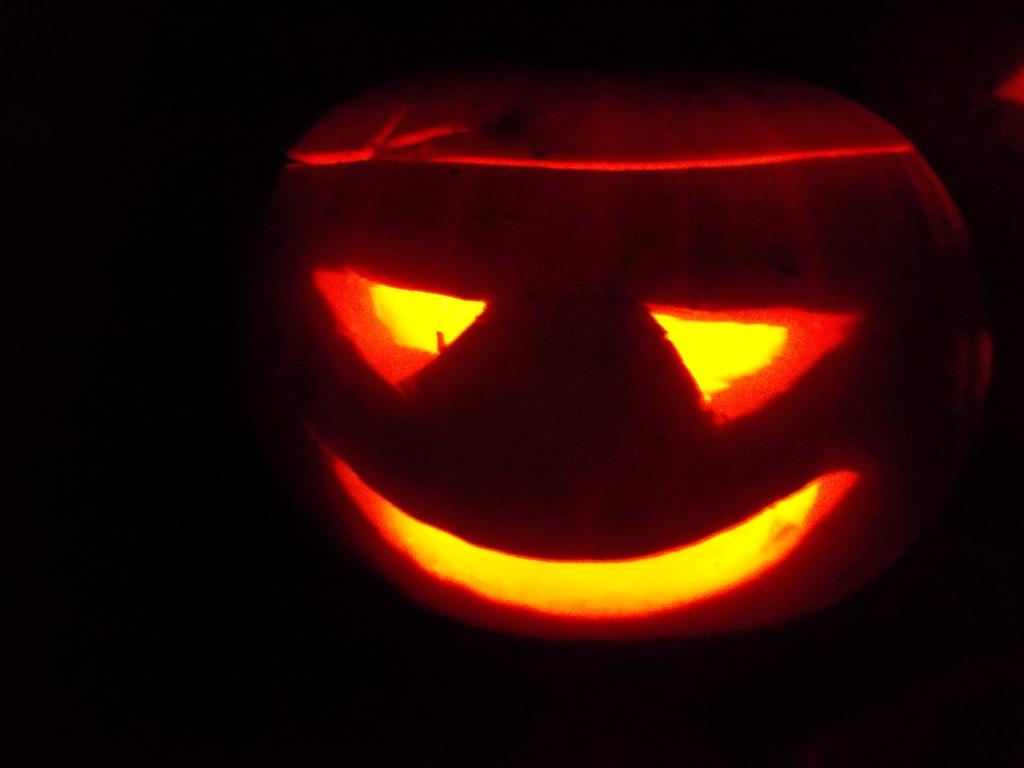What is the main subject of the image? The main subject of the image is a carved pumpkin. What is the name given to a carved pumpkin like the one in the image? The carved pumpkin is called a Jack-o'-lantern. What color is the background of the image? The background of the image is black. Can you see a giraffe shaking a tree in the image? No, there is no giraffe or tree present in the image. 